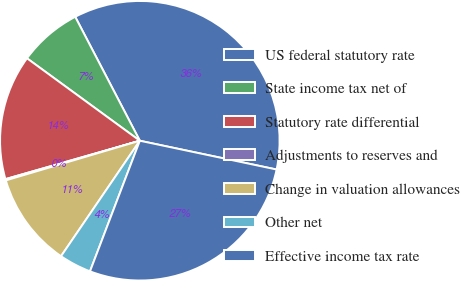Convert chart to OTSL. <chart><loc_0><loc_0><loc_500><loc_500><pie_chart><fcel>US federal statutory rate<fcel>State income tax net of<fcel>Statutory rate differential<fcel>Adjustments to reserves and<fcel>Change in valuation allowances<fcel>Other net<fcel>Effective income tax rate<nl><fcel>35.95%<fcel>7.31%<fcel>14.47%<fcel>0.15%<fcel>10.89%<fcel>3.73%<fcel>27.5%<nl></chart> 